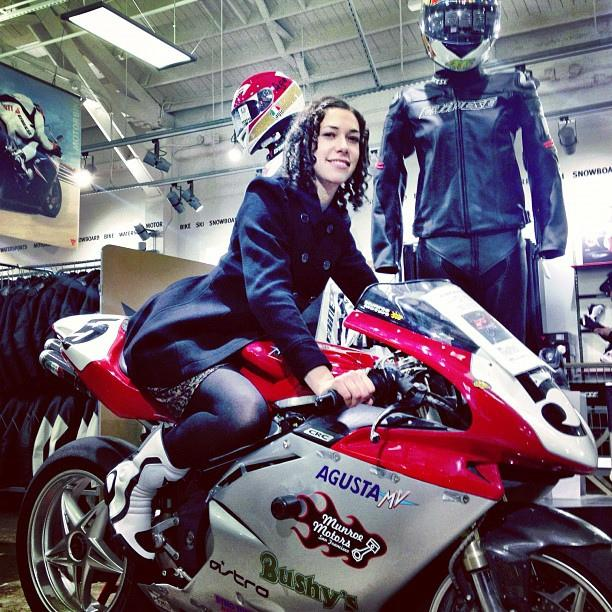What does the woman have on her feet?

Choices:
A) seashells
B) sneakers
C) sandals
D) boots boots 